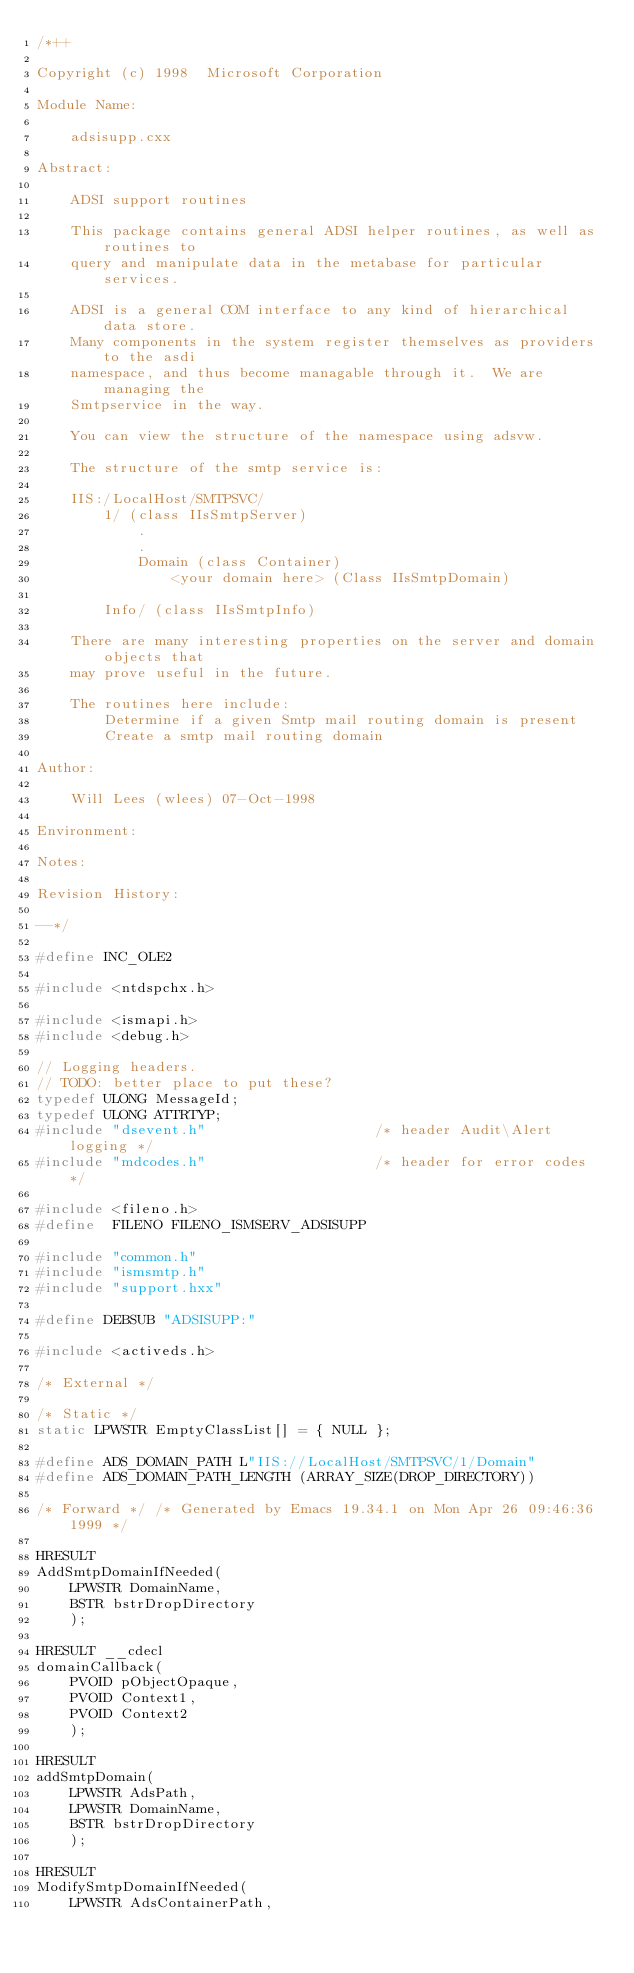Convert code to text. <code><loc_0><loc_0><loc_500><loc_500><_C++_>/*++

Copyright (c) 1998  Microsoft Corporation

Module Name:

    adsisupp.cxx

Abstract:

    ADSI support routines

    This package contains general ADSI helper routines, as well as routines to
    query and manipulate data in the metabase for particular services.

    ADSI is a general COM interface to any kind of hierarchical data store.
    Many components in the system register themselves as providers to the asdi
    namespace, and thus become managable through it.  We are managing the
    Smtpservice in the way.

    You can view the structure of the namespace using adsvw.

    The structure of the smtp service is:

    IIS:/LocalHost/SMTPSVC/
        1/ (class IIsSmtpServer)
            .
            .
            Domain (class Container)
                <your domain here> (Class IIsSmtpDomain)

        Info/ (class IIsSmtpInfo)

    There are many interesting properties on the server and domain objects that
    may prove useful in the future.

    The routines here include:
        Determine if a given Smtp mail routing domain is present
        Create a smtp mail routing domain

Author:

    Will Lees (wlees) 07-Oct-1998

Environment:

Notes:

Revision History:

--*/

#define INC_OLE2

#include <ntdspchx.h>

#include <ismapi.h>
#include <debug.h>

// Logging headers.
// TODO: better place to put these?
typedef ULONG MessageId;
typedef ULONG ATTRTYP;
#include "dsevent.h"                    /* header Audit\Alert logging */
#include "mdcodes.h"                    /* header for error codes */

#include <fileno.h>
#define  FILENO FILENO_ISMSERV_ADSISUPP

#include "common.h"
#include "ismsmtp.h"
#include "support.hxx"

#define DEBSUB "ADSISUPP:"

#include <activeds.h>

/* External */

/* Static */
static LPWSTR EmptyClassList[] = { NULL };

#define ADS_DOMAIN_PATH L"IIS://LocalHost/SMTPSVC/1/Domain"
#define ADS_DOMAIN_PATH_LENGTH (ARRAY_SIZE(DROP_DIRECTORY))

/* Forward */ /* Generated by Emacs 19.34.1 on Mon Apr 26 09:46:36 1999 */

HRESULT
AddSmtpDomainIfNeeded(
    LPWSTR DomainName,
    BSTR bstrDropDirectory
    );

HRESULT __cdecl
domainCallback(
    PVOID pObjectOpaque,
    PVOID Context1,
    PVOID Context2
    );

HRESULT
addSmtpDomain(
    LPWSTR AdsPath,
    LPWSTR DomainName,
    BSTR bstrDropDirectory
    );

HRESULT
ModifySmtpDomainIfNeeded(
    LPWSTR AdsContainerPath,</code> 